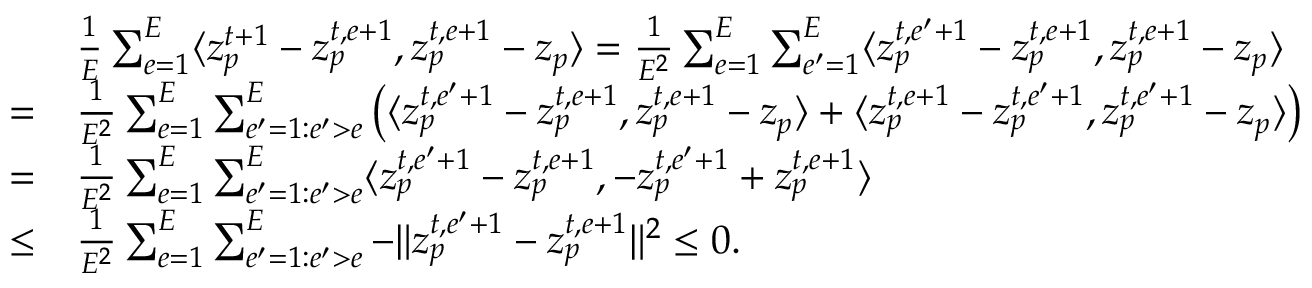Convert formula to latex. <formula><loc_0><loc_0><loc_500><loc_500>\begin{array} { r l } & { \frac { 1 } { E } \sum _ { e = 1 } ^ { E } \langle z _ { p } ^ { t + 1 } - z _ { p } ^ { t , e + 1 } , z _ { p } ^ { t , e + 1 } - z _ { p } \rangle = \frac { 1 } { E ^ { 2 } } \sum _ { e = 1 } ^ { E } \sum _ { e ^ { \prime } = 1 } ^ { E } \langle z _ { p } ^ { t , e ^ { \prime } + 1 } - z _ { p } ^ { t , e + 1 } , z _ { p } ^ { t , e + 1 } - z _ { p } \rangle } \\ { = } & { \frac { 1 } { E ^ { 2 } } \sum _ { e = 1 } ^ { E } \sum _ { e ^ { \prime } = 1 \colon e ^ { \prime } > e } ^ { E } \left ( \langle z _ { p } ^ { t , e ^ { \prime } + 1 } - z _ { p } ^ { t , e + 1 } , z _ { p } ^ { t , e + 1 } - z _ { p } \rangle + \langle z _ { p } ^ { t , e + 1 } - z _ { p } ^ { t , e ^ { \prime } + 1 } , z _ { p } ^ { t , e ^ { \prime } + 1 } - z _ { p } \rangle \right ) } \\ { = } & { \frac { 1 } { E ^ { 2 } } \sum _ { e = 1 } ^ { E } \sum _ { e ^ { \prime } = 1 \colon e ^ { \prime } > e } ^ { E } \langle z _ { p } ^ { t , e ^ { \prime } + 1 } - z _ { p } ^ { t , e + 1 } , - z _ { p } ^ { t , e ^ { \prime } + 1 } + z _ { p } ^ { t , e + 1 } \rangle } \\ { \leq } & { \frac { 1 } { E ^ { 2 } } \sum _ { e = 1 } ^ { E } \sum _ { e ^ { \prime } = 1 \colon e ^ { \prime } > e } ^ { E } - \| z _ { p } ^ { t , e ^ { \prime } + 1 } - z _ { p } ^ { t , e + 1 } \| ^ { 2 } \leq 0 . } \end{array}</formula> 